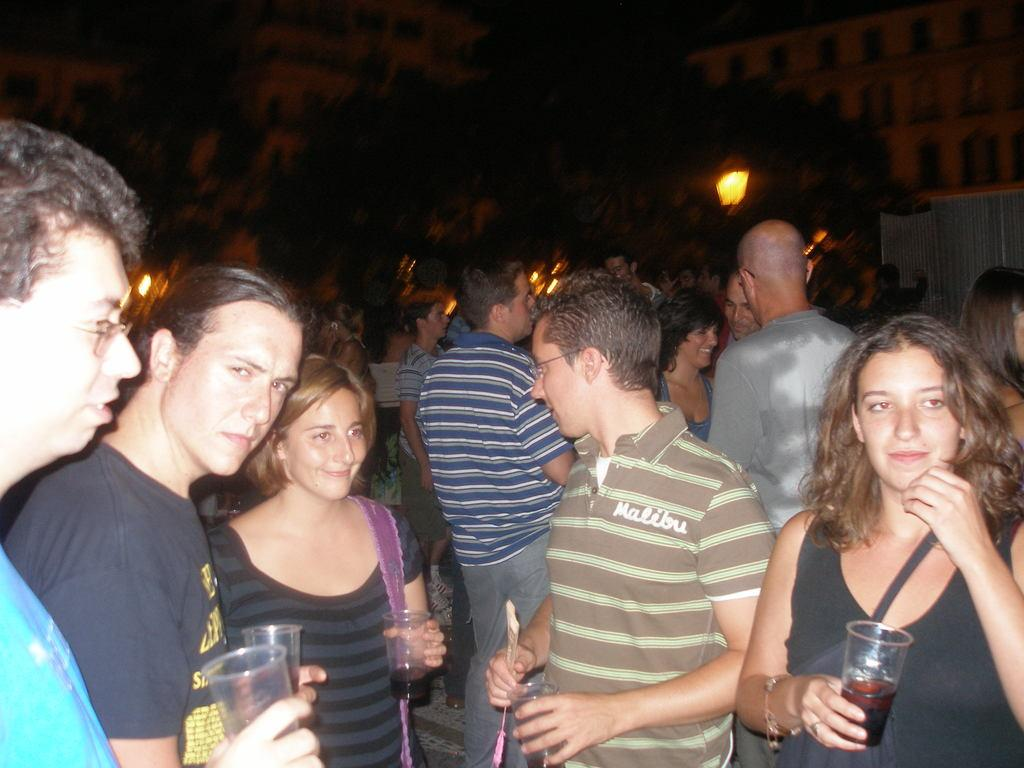What are the people in the image doing? The people in the image are standing and holding glasses. What can be seen in the background of the image? There is a building and a tree visible in the background of the image. What type of flowers can be seen growing near the tree in the image? There are no flowers visible in the image; only a building and a tree can be seen in the background. 